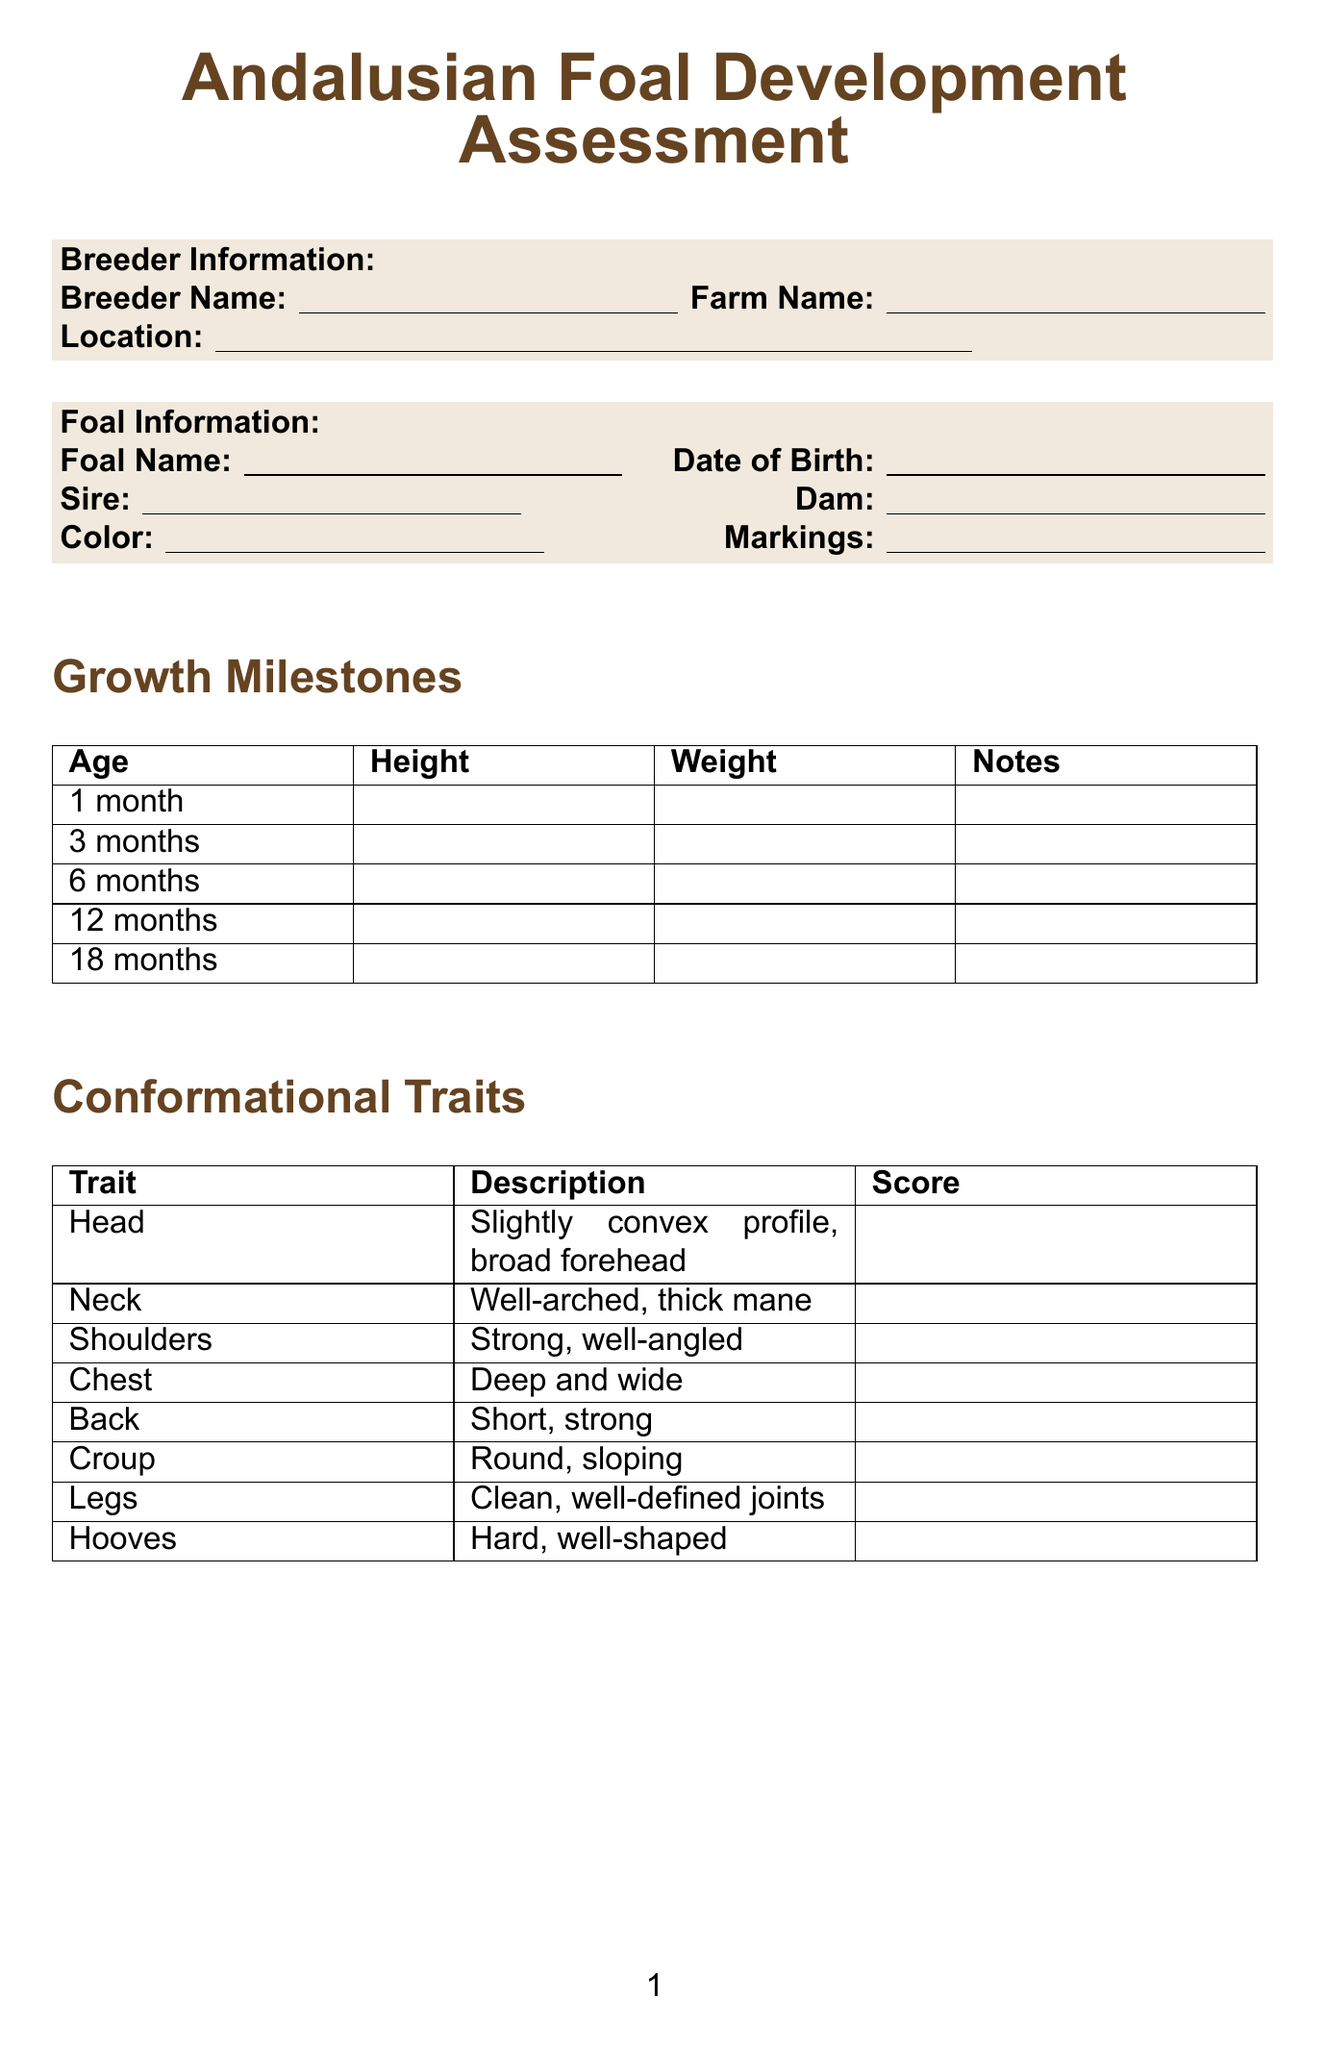What is the title of the document? The document title is presented at the top, indicating the main focus of the form.
Answer: Andalusian Foal Development Assessment What age is the foal at the first milestone? The first milestone notes the age of 1 month, which is recorded in the growth milestones section.
Answer: 1 month What are the growth milestones listed? The document categorizes the growth milestones at various ages, including 1 month, 3 months, 6 months, 12 months, and 18 months.
Answer: 1 month, 3 months, 6 months, 12 months, 18 months What is the description of the head trait? The head trait description can be found in the conformational traits section of the document.
Answer: Slightly convex profile, broad forehead Which gait is described as collected, balanced, uphill? The gait descriptions include specific terms for each, allowing identification of their characteristics.
Answer: Canter What checks are included in the health section? The health checks section lists specific health checks that are crucial for the foal's well-being.
Answer: Vaccinations, Deworming, Hoof care, Dental check 